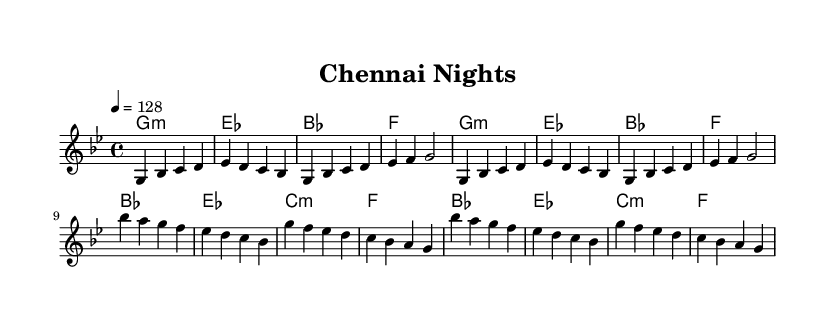what is the key signature of this music? The key signature shown in the music sheet is G minor, which typically features two flats (B♭, E♭). This can be identified from the global section of the code where it specifies the key.
Answer: G minor what is the time signature of this music? The time signature is 4/4, indicated in the global section. This means there are four beats per measure, and the quarter note gets one beat.
Answer: 4/4 what is the tempo marking for this piece? The tempo marking given is "4 = 128," which indicates that there are 128 beats per minute when played in the standard metrical pace of 4 beats per measure.
Answer: 128 how many measures are in the verse section? The verse section consists of two repetitions of the same eight-measure phrase, totaling 16 measures: 8 measures for the first round and 8 for the repeat.
Answer: 16 what is the first chord of the chorus? The first chord of the chorus is B♭ major, which is indicated at the beginning of the chorus section in the chord mode described.
Answer: B♭ major how does the rhythm change between the verse and chorus? The rhythm remains consistent in 4/4 time throughout; however, the melody and harmony present different progressions and emotional emphasis, reflecting a shift typical of K-Pop transitions between verse and chorus.
Answer: Consistent what cultural elements could be represented in a K-Pop music video featuring this composition? While the sheet music does not explicitly showcase Tamil elements, it can be paired with visuals from Tamil culture, such as landmarks or traditional attire, enhancing the cultural representation in a stylized K-Pop context.
Answer: Cultural visuals 